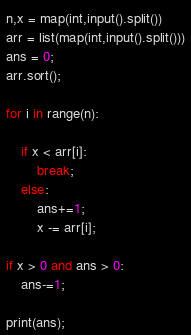<code> <loc_0><loc_0><loc_500><loc_500><_Python_>n,x = map(int,input().split())
arr = list(map(int,input().split()))
ans = 0;
arr.sort();

for i in range(n):

	if x < arr[i]:
		break;
	else:
		ans+=1;
		x -= arr[i];

if x > 0 and ans > 0:
	ans-=1;

print(ans);</code> 